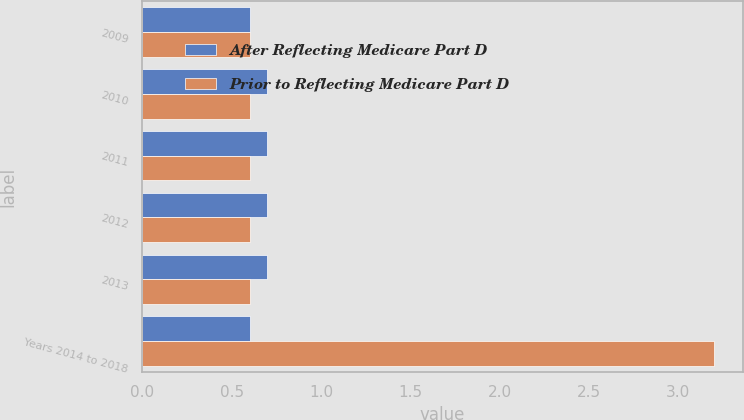Convert chart to OTSL. <chart><loc_0><loc_0><loc_500><loc_500><stacked_bar_chart><ecel><fcel>2009<fcel>2010<fcel>2011<fcel>2012<fcel>2013<fcel>Years 2014 to 2018<nl><fcel>After Reflecting Medicare Part D<fcel>0.6<fcel>0.7<fcel>0.7<fcel>0.7<fcel>0.7<fcel>0.6<nl><fcel>Prior to Reflecting Medicare Part D<fcel>0.6<fcel>0.6<fcel>0.6<fcel>0.6<fcel>0.6<fcel>3.2<nl></chart> 